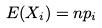<formula> <loc_0><loc_0><loc_500><loc_500>E ( X _ { i } ) = n p _ { i }</formula> 